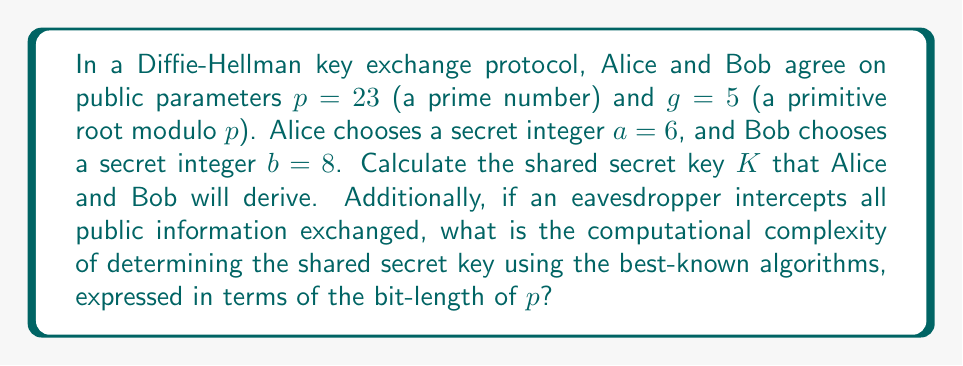Solve this math problem. 1. Alice computes her public key:
   $A \equiv g^a \pmod{p}$
   $A \equiv 5^6 \pmod{23} \equiv 8$

2. Bob computes his public key:
   $B \equiv g^b \pmod{p}$
   $B \equiv 5^8 \pmod{23} \equiv 16$

3. Alice computes the shared secret:
   $K_A \equiv B^a \pmod{p}$
   $K_A \equiv 16^6 \pmod{23} \equiv 9$

4. Bob computes the shared secret:
   $K_B \equiv A^b \pmod{p}$
   $K_B \equiv 8^8 \pmod{23} \equiv 9$

5. The shared secret key $K = K_A = K_B = 9$

6. For the computational complexity:
   The best-known algorithm for solving the discrete logarithm problem (which an eavesdropper would need to do to determine the shared secret) is the General Number Field Sieve (GNFS).
   The complexity of GNFS is:
   $O(e^{((64/9)^{1/3} + o(1))(\ln p)^{1/3}(\ln \ln p)^{2/3}})$

   This is sub-exponential in the bit-length of $p$, commonly expressed as:
   $L_p[1/3, (64/9)^{1/3}] \approx L_p[1/3, 1.923]$

   Where $L_p[\alpha, c] = e^{(c+o(1))(\ln p)^\alpha (\ln \ln p)^{1-\alpha}}$
Answer: $K = 9$; Complexity: $L_p[1/3, 1.923]$ 